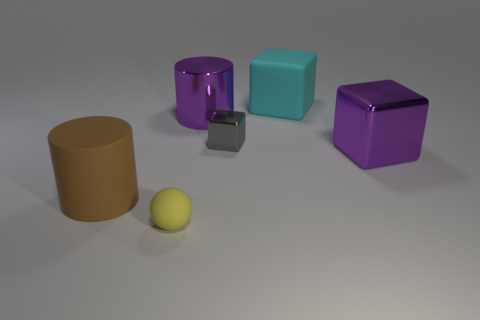Are there any large things that have the same color as the shiny cylinder?
Provide a short and direct response. Yes. There is a purple object in front of the gray object; is there a cylinder behind it?
Offer a very short reply. Yes. Is there a block that has the same material as the small yellow object?
Make the answer very short. Yes. There is a block behind the big cylinder that is behind the gray object; what is it made of?
Keep it short and to the point. Rubber. What is the material of the large object that is in front of the gray object and to the left of the gray cube?
Ensure brevity in your answer.  Rubber. Is the number of large cyan blocks that are to the right of the brown object the same as the number of gray blocks?
Make the answer very short. Yes. How many large purple things have the same shape as the cyan matte thing?
Offer a terse response. 1. What is the size of the object in front of the big matte object that is in front of the purple shiny thing that is to the left of the big purple block?
Keep it short and to the point. Small. Is the cylinder that is behind the big purple shiny block made of the same material as the large purple cube?
Offer a very short reply. Yes. Are there an equal number of large rubber cubes on the left side of the large brown thing and large purple things in front of the tiny gray object?
Your answer should be very brief. No. 